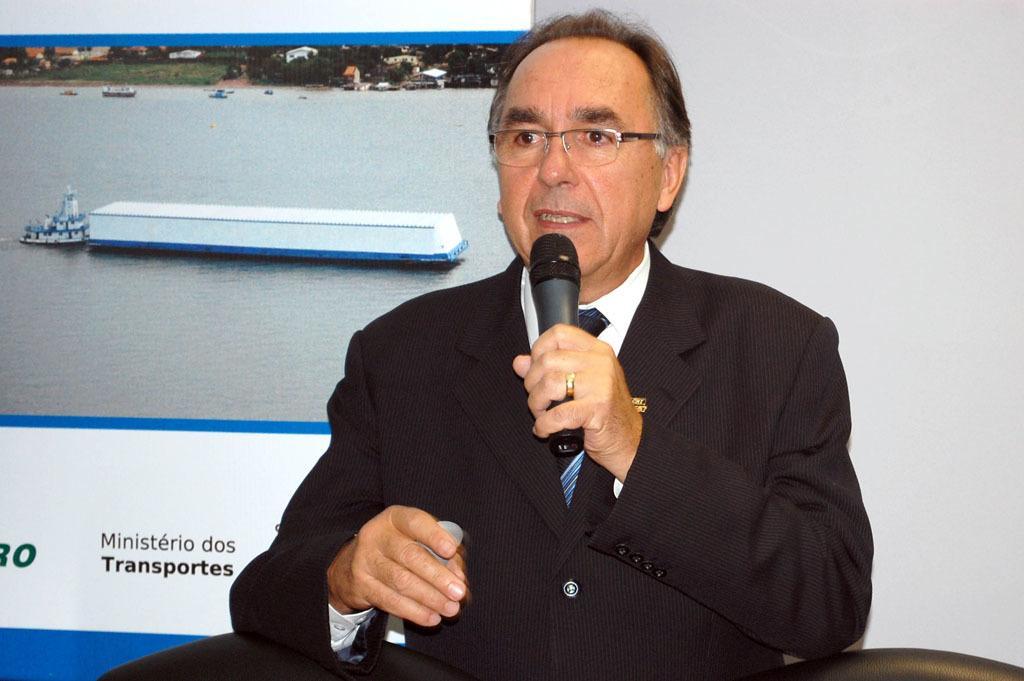Describe this image in one or two sentences. In the image a man wearing black coat is sitting and speaking, behind him there is a logo poster , to the right side there is a white color wall. 